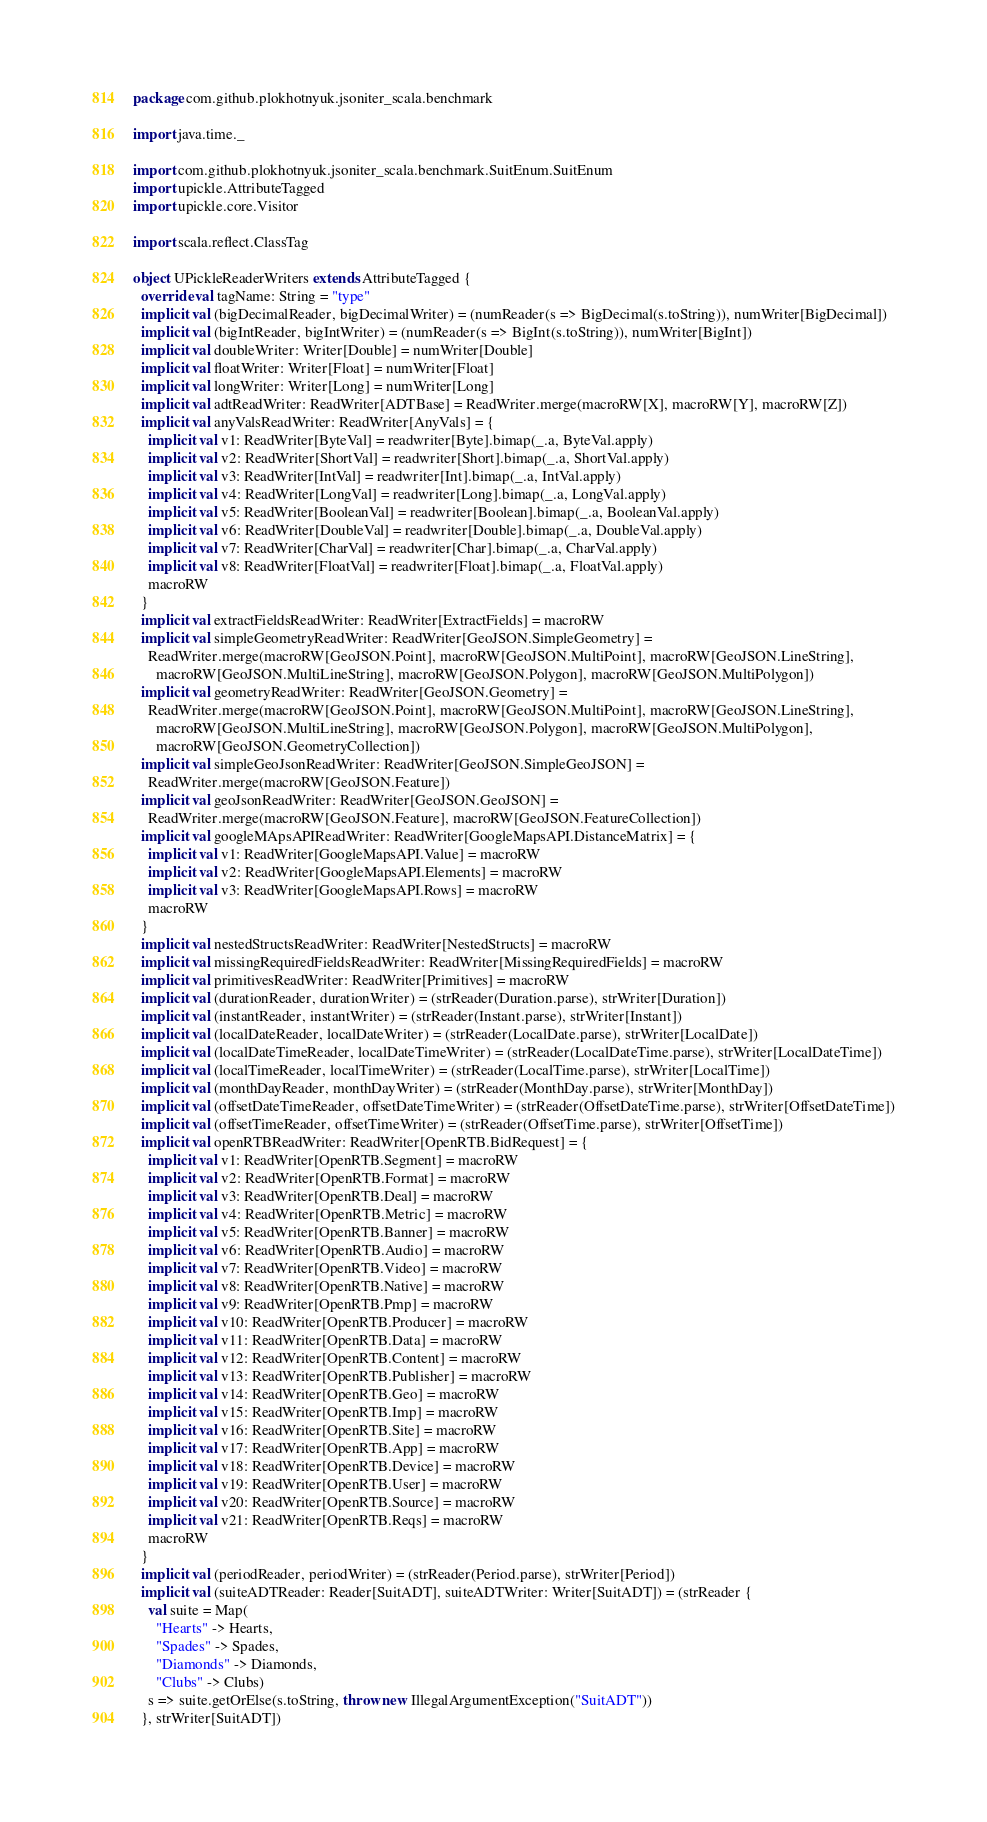<code> <loc_0><loc_0><loc_500><loc_500><_Scala_>package com.github.plokhotnyuk.jsoniter_scala.benchmark

import java.time._

import com.github.plokhotnyuk.jsoniter_scala.benchmark.SuitEnum.SuitEnum
import upickle.AttributeTagged
import upickle.core.Visitor

import scala.reflect.ClassTag

object UPickleReaderWriters extends AttributeTagged {
  override val tagName: String = "type"
  implicit val (bigDecimalReader, bigDecimalWriter) = (numReader(s => BigDecimal(s.toString)), numWriter[BigDecimal])
  implicit val (bigIntReader, bigIntWriter) = (numReader(s => BigInt(s.toString)), numWriter[BigInt])
  implicit val doubleWriter: Writer[Double] = numWriter[Double]
  implicit val floatWriter: Writer[Float] = numWriter[Float]
  implicit val longWriter: Writer[Long] = numWriter[Long]
  implicit val adtReadWriter: ReadWriter[ADTBase] = ReadWriter.merge(macroRW[X], macroRW[Y], macroRW[Z])
  implicit val anyValsReadWriter: ReadWriter[AnyVals] = {
    implicit val v1: ReadWriter[ByteVal] = readwriter[Byte].bimap(_.a, ByteVal.apply)
    implicit val v2: ReadWriter[ShortVal] = readwriter[Short].bimap(_.a, ShortVal.apply)
    implicit val v3: ReadWriter[IntVal] = readwriter[Int].bimap(_.a, IntVal.apply)
    implicit val v4: ReadWriter[LongVal] = readwriter[Long].bimap(_.a, LongVal.apply)
    implicit val v5: ReadWriter[BooleanVal] = readwriter[Boolean].bimap(_.a, BooleanVal.apply)
    implicit val v6: ReadWriter[DoubleVal] = readwriter[Double].bimap(_.a, DoubleVal.apply)
    implicit val v7: ReadWriter[CharVal] = readwriter[Char].bimap(_.a, CharVal.apply)
    implicit val v8: ReadWriter[FloatVal] = readwriter[Float].bimap(_.a, FloatVal.apply)
    macroRW
  }
  implicit val extractFieldsReadWriter: ReadWriter[ExtractFields] = macroRW
  implicit val simpleGeometryReadWriter: ReadWriter[GeoJSON.SimpleGeometry] =
    ReadWriter.merge(macroRW[GeoJSON.Point], macroRW[GeoJSON.MultiPoint], macroRW[GeoJSON.LineString],
      macroRW[GeoJSON.MultiLineString], macroRW[GeoJSON.Polygon], macroRW[GeoJSON.MultiPolygon])
  implicit val geometryReadWriter: ReadWriter[GeoJSON.Geometry] =
    ReadWriter.merge(macroRW[GeoJSON.Point], macroRW[GeoJSON.MultiPoint], macroRW[GeoJSON.LineString],
      macroRW[GeoJSON.MultiLineString], macroRW[GeoJSON.Polygon], macroRW[GeoJSON.MultiPolygon],
      macroRW[GeoJSON.GeometryCollection])
  implicit val simpleGeoJsonReadWriter: ReadWriter[GeoJSON.SimpleGeoJSON] =
    ReadWriter.merge(macroRW[GeoJSON.Feature])
  implicit val geoJsonReadWriter: ReadWriter[GeoJSON.GeoJSON] =
    ReadWriter.merge(macroRW[GeoJSON.Feature], macroRW[GeoJSON.FeatureCollection])
  implicit val googleMApsAPIReadWriter: ReadWriter[GoogleMapsAPI.DistanceMatrix] = {
    implicit val v1: ReadWriter[GoogleMapsAPI.Value] = macroRW
    implicit val v2: ReadWriter[GoogleMapsAPI.Elements] = macroRW
    implicit val v3: ReadWriter[GoogleMapsAPI.Rows] = macroRW
    macroRW
  }
  implicit val nestedStructsReadWriter: ReadWriter[NestedStructs] = macroRW
  implicit val missingRequiredFieldsReadWriter: ReadWriter[MissingRequiredFields] = macroRW
  implicit val primitivesReadWriter: ReadWriter[Primitives] = macroRW
  implicit val (durationReader, durationWriter) = (strReader(Duration.parse), strWriter[Duration])
  implicit val (instantReader, instantWriter) = (strReader(Instant.parse), strWriter[Instant])
  implicit val (localDateReader, localDateWriter) = (strReader(LocalDate.parse), strWriter[LocalDate])
  implicit val (localDateTimeReader, localDateTimeWriter) = (strReader(LocalDateTime.parse), strWriter[LocalDateTime])
  implicit val (localTimeReader, localTimeWriter) = (strReader(LocalTime.parse), strWriter[LocalTime])
  implicit val (monthDayReader, monthDayWriter) = (strReader(MonthDay.parse), strWriter[MonthDay])
  implicit val (offsetDateTimeReader, offsetDateTimeWriter) = (strReader(OffsetDateTime.parse), strWriter[OffsetDateTime])
  implicit val (offsetTimeReader, offsetTimeWriter) = (strReader(OffsetTime.parse), strWriter[OffsetTime])
  implicit val openRTBReadWriter: ReadWriter[OpenRTB.BidRequest] = {
    implicit val v1: ReadWriter[OpenRTB.Segment] = macroRW
    implicit val v2: ReadWriter[OpenRTB.Format] = macroRW
    implicit val v3: ReadWriter[OpenRTB.Deal] = macroRW
    implicit val v4: ReadWriter[OpenRTB.Metric] = macroRW
    implicit val v5: ReadWriter[OpenRTB.Banner] = macroRW
    implicit val v6: ReadWriter[OpenRTB.Audio] = macroRW
    implicit val v7: ReadWriter[OpenRTB.Video] = macroRW
    implicit val v8: ReadWriter[OpenRTB.Native] = macroRW
    implicit val v9: ReadWriter[OpenRTB.Pmp] = macroRW
    implicit val v10: ReadWriter[OpenRTB.Producer] = macroRW
    implicit val v11: ReadWriter[OpenRTB.Data] = macroRW
    implicit val v12: ReadWriter[OpenRTB.Content] = macroRW
    implicit val v13: ReadWriter[OpenRTB.Publisher] = macroRW
    implicit val v14: ReadWriter[OpenRTB.Geo] = macroRW
    implicit val v15: ReadWriter[OpenRTB.Imp] = macroRW
    implicit val v16: ReadWriter[OpenRTB.Site] = macroRW
    implicit val v17: ReadWriter[OpenRTB.App] = macroRW
    implicit val v18: ReadWriter[OpenRTB.Device] = macroRW
    implicit val v19: ReadWriter[OpenRTB.User] = macroRW
    implicit val v20: ReadWriter[OpenRTB.Source] = macroRW
    implicit val v21: ReadWriter[OpenRTB.Reqs] = macroRW
    macroRW
  }
  implicit val (periodReader, periodWriter) = (strReader(Period.parse), strWriter[Period])
  implicit val (suiteADTReader: Reader[SuitADT], suiteADTWriter: Writer[SuitADT]) = (strReader {
    val suite = Map(
      "Hearts" -> Hearts,
      "Spades" -> Spades,
      "Diamonds" -> Diamonds,
      "Clubs" -> Clubs)
    s => suite.getOrElse(s.toString, throw new IllegalArgumentException("SuitADT"))
  }, strWriter[SuitADT])</code> 